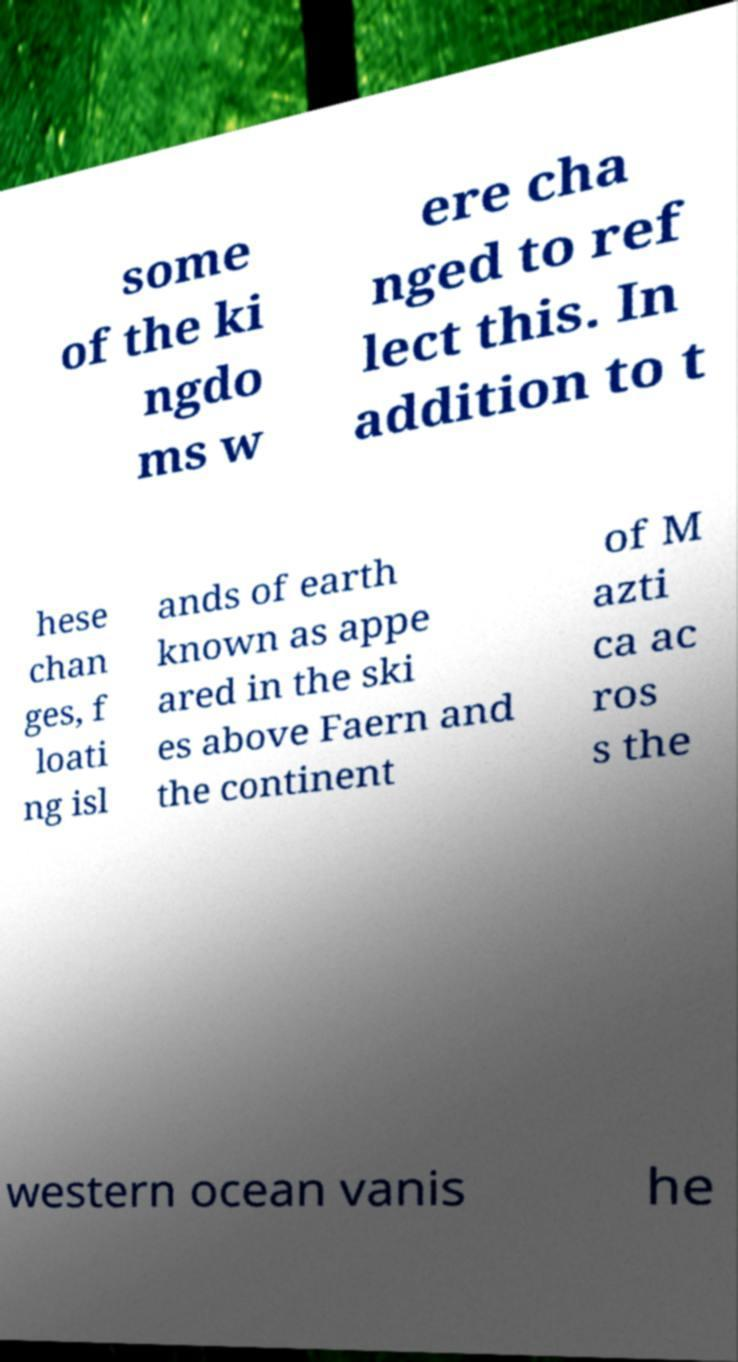Can you accurately transcribe the text from the provided image for me? some of the ki ngdo ms w ere cha nged to ref lect this. In addition to t hese chan ges, f loati ng isl ands of earth known as appe ared in the ski es above Faern and the continent of M azti ca ac ros s the western ocean vanis he 